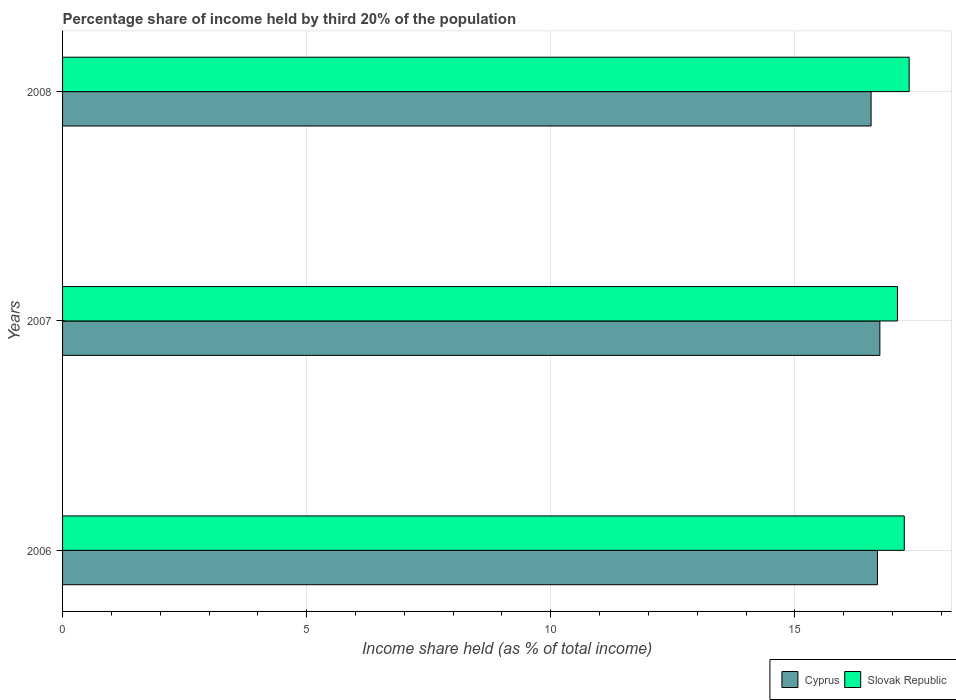How many different coloured bars are there?
Provide a succinct answer. 2. How many bars are there on the 1st tick from the bottom?
Provide a short and direct response. 2. What is the share of income held by third 20% of the population in Slovak Republic in 2008?
Offer a terse response. 17.34. Across all years, what is the maximum share of income held by third 20% of the population in Cyprus?
Your answer should be very brief. 16.74. Across all years, what is the minimum share of income held by third 20% of the population in Slovak Republic?
Offer a terse response. 17.1. In which year was the share of income held by third 20% of the population in Cyprus maximum?
Give a very brief answer. 2007. In which year was the share of income held by third 20% of the population in Cyprus minimum?
Give a very brief answer. 2008. What is the total share of income held by third 20% of the population in Cyprus in the graph?
Ensure brevity in your answer.  49.99. What is the difference between the share of income held by third 20% of the population in Cyprus in 2006 and that in 2008?
Your response must be concise. 0.13. What is the difference between the share of income held by third 20% of the population in Slovak Republic in 2008 and the share of income held by third 20% of the population in Cyprus in 2007?
Your answer should be very brief. 0.6. What is the average share of income held by third 20% of the population in Cyprus per year?
Your answer should be very brief. 16.66. In the year 2007, what is the difference between the share of income held by third 20% of the population in Slovak Republic and share of income held by third 20% of the population in Cyprus?
Provide a short and direct response. 0.36. What is the ratio of the share of income held by third 20% of the population in Slovak Republic in 2006 to that in 2007?
Your answer should be very brief. 1.01. Is the share of income held by third 20% of the population in Slovak Republic in 2006 less than that in 2008?
Provide a short and direct response. Yes. Is the difference between the share of income held by third 20% of the population in Slovak Republic in 2006 and 2008 greater than the difference between the share of income held by third 20% of the population in Cyprus in 2006 and 2008?
Your answer should be very brief. No. What is the difference between the highest and the second highest share of income held by third 20% of the population in Cyprus?
Ensure brevity in your answer.  0.05. What is the difference between the highest and the lowest share of income held by third 20% of the population in Cyprus?
Make the answer very short. 0.18. What does the 2nd bar from the top in 2008 represents?
Your response must be concise. Cyprus. What does the 2nd bar from the bottom in 2007 represents?
Keep it short and to the point. Slovak Republic. How many bars are there?
Your response must be concise. 6. Does the graph contain any zero values?
Keep it short and to the point. No. Does the graph contain grids?
Keep it short and to the point. Yes. Where does the legend appear in the graph?
Give a very brief answer. Bottom right. What is the title of the graph?
Keep it short and to the point. Percentage share of income held by third 20% of the population. What is the label or title of the X-axis?
Give a very brief answer. Income share held (as % of total income). What is the Income share held (as % of total income) of Cyprus in 2006?
Your response must be concise. 16.69. What is the Income share held (as % of total income) of Slovak Republic in 2006?
Your response must be concise. 17.24. What is the Income share held (as % of total income) of Cyprus in 2007?
Keep it short and to the point. 16.74. What is the Income share held (as % of total income) in Cyprus in 2008?
Provide a short and direct response. 16.56. What is the Income share held (as % of total income) of Slovak Republic in 2008?
Offer a terse response. 17.34. Across all years, what is the maximum Income share held (as % of total income) in Cyprus?
Offer a terse response. 16.74. Across all years, what is the maximum Income share held (as % of total income) in Slovak Republic?
Your response must be concise. 17.34. Across all years, what is the minimum Income share held (as % of total income) in Cyprus?
Your response must be concise. 16.56. What is the total Income share held (as % of total income) of Cyprus in the graph?
Your answer should be very brief. 49.99. What is the total Income share held (as % of total income) of Slovak Republic in the graph?
Keep it short and to the point. 51.68. What is the difference between the Income share held (as % of total income) in Cyprus in 2006 and that in 2007?
Your answer should be compact. -0.05. What is the difference between the Income share held (as % of total income) in Slovak Republic in 2006 and that in 2007?
Provide a short and direct response. 0.14. What is the difference between the Income share held (as % of total income) of Cyprus in 2006 and that in 2008?
Provide a short and direct response. 0.13. What is the difference between the Income share held (as % of total income) in Slovak Republic in 2006 and that in 2008?
Your response must be concise. -0.1. What is the difference between the Income share held (as % of total income) of Cyprus in 2007 and that in 2008?
Your response must be concise. 0.18. What is the difference between the Income share held (as % of total income) in Slovak Republic in 2007 and that in 2008?
Your response must be concise. -0.24. What is the difference between the Income share held (as % of total income) in Cyprus in 2006 and the Income share held (as % of total income) in Slovak Republic in 2007?
Make the answer very short. -0.41. What is the difference between the Income share held (as % of total income) of Cyprus in 2006 and the Income share held (as % of total income) of Slovak Republic in 2008?
Offer a very short reply. -0.65. What is the average Income share held (as % of total income) in Cyprus per year?
Give a very brief answer. 16.66. What is the average Income share held (as % of total income) in Slovak Republic per year?
Offer a terse response. 17.23. In the year 2006, what is the difference between the Income share held (as % of total income) in Cyprus and Income share held (as % of total income) in Slovak Republic?
Give a very brief answer. -0.55. In the year 2007, what is the difference between the Income share held (as % of total income) of Cyprus and Income share held (as % of total income) of Slovak Republic?
Offer a very short reply. -0.36. In the year 2008, what is the difference between the Income share held (as % of total income) in Cyprus and Income share held (as % of total income) in Slovak Republic?
Offer a terse response. -0.78. What is the ratio of the Income share held (as % of total income) of Cyprus in 2006 to that in 2007?
Offer a terse response. 1. What is the ratio of the Income share held (as % of total income) of Slovak Republic in 2006 to that in 2007?
Your response must be concise. 1.01. What is the ratio of the Income share held (as % of total income) of Cyprus in 2006 to that in 2008?
Keep it short and to the point. 1.01. What is the ratio of the Income share held (as % of total income) of Cyprus in 2007 to that in 2008?
Offer a terse response. 1.01. What is the ratio of the Income share held (as % of total income) in Slovak Republic in 2007 to that in 2008?
Ensure brevity in your answer.  0.99. What is the difference between the highest and the second highest Income share held (as % of total income) of Cyprus?
Give a very brief answer. 0.05. What is the difference between the highest and the lowest Income share held (as % of total income) of Cyprus?
Provide a short and direct response. 0.18. What is the difference between the highest and the lowest Income share held (as % of total income) in Slovak Republic?
Make the answer very short. 0.24. 